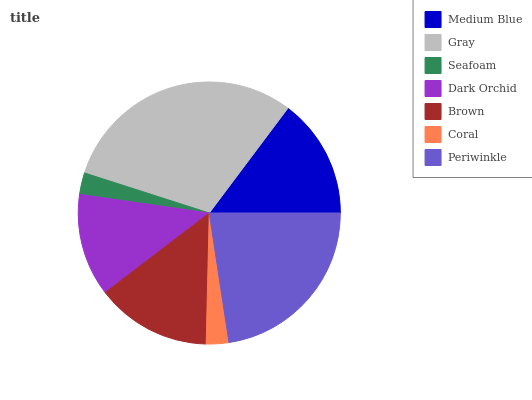Is Seafoam the minimum?
Answer yes or no. Yes. Is Gray the maximum?
Answer yes or no. Yes. Is Gray the minimum?
Answer yes or no. No. Is Seafoam the maximum?
Answer yes or no. No. Is Gray greater than Seafoam?
Answer yes or no. Yes. Is Seafoam less than Gray?
Answer yes or no. Yes. Is Seafoam greater than Gray?
Answer yes or no. No. Is Gray less than Seafoam?
Answer yes or no. No. Is Brown the high median?
Answer yes or no. Yes. Is Brown the low median?
Answer yes or no. Yes. Is Coral the high median?
Answer yes or no. No. Is Coral the low median?
Answer yes or no. No. 